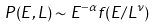<formula> <loc_0><loc_0><loc_500><loc_500>P ( E , L ) \sim E ^ { - \alpha } f ( E / L ^ { \nu } )</formula> 